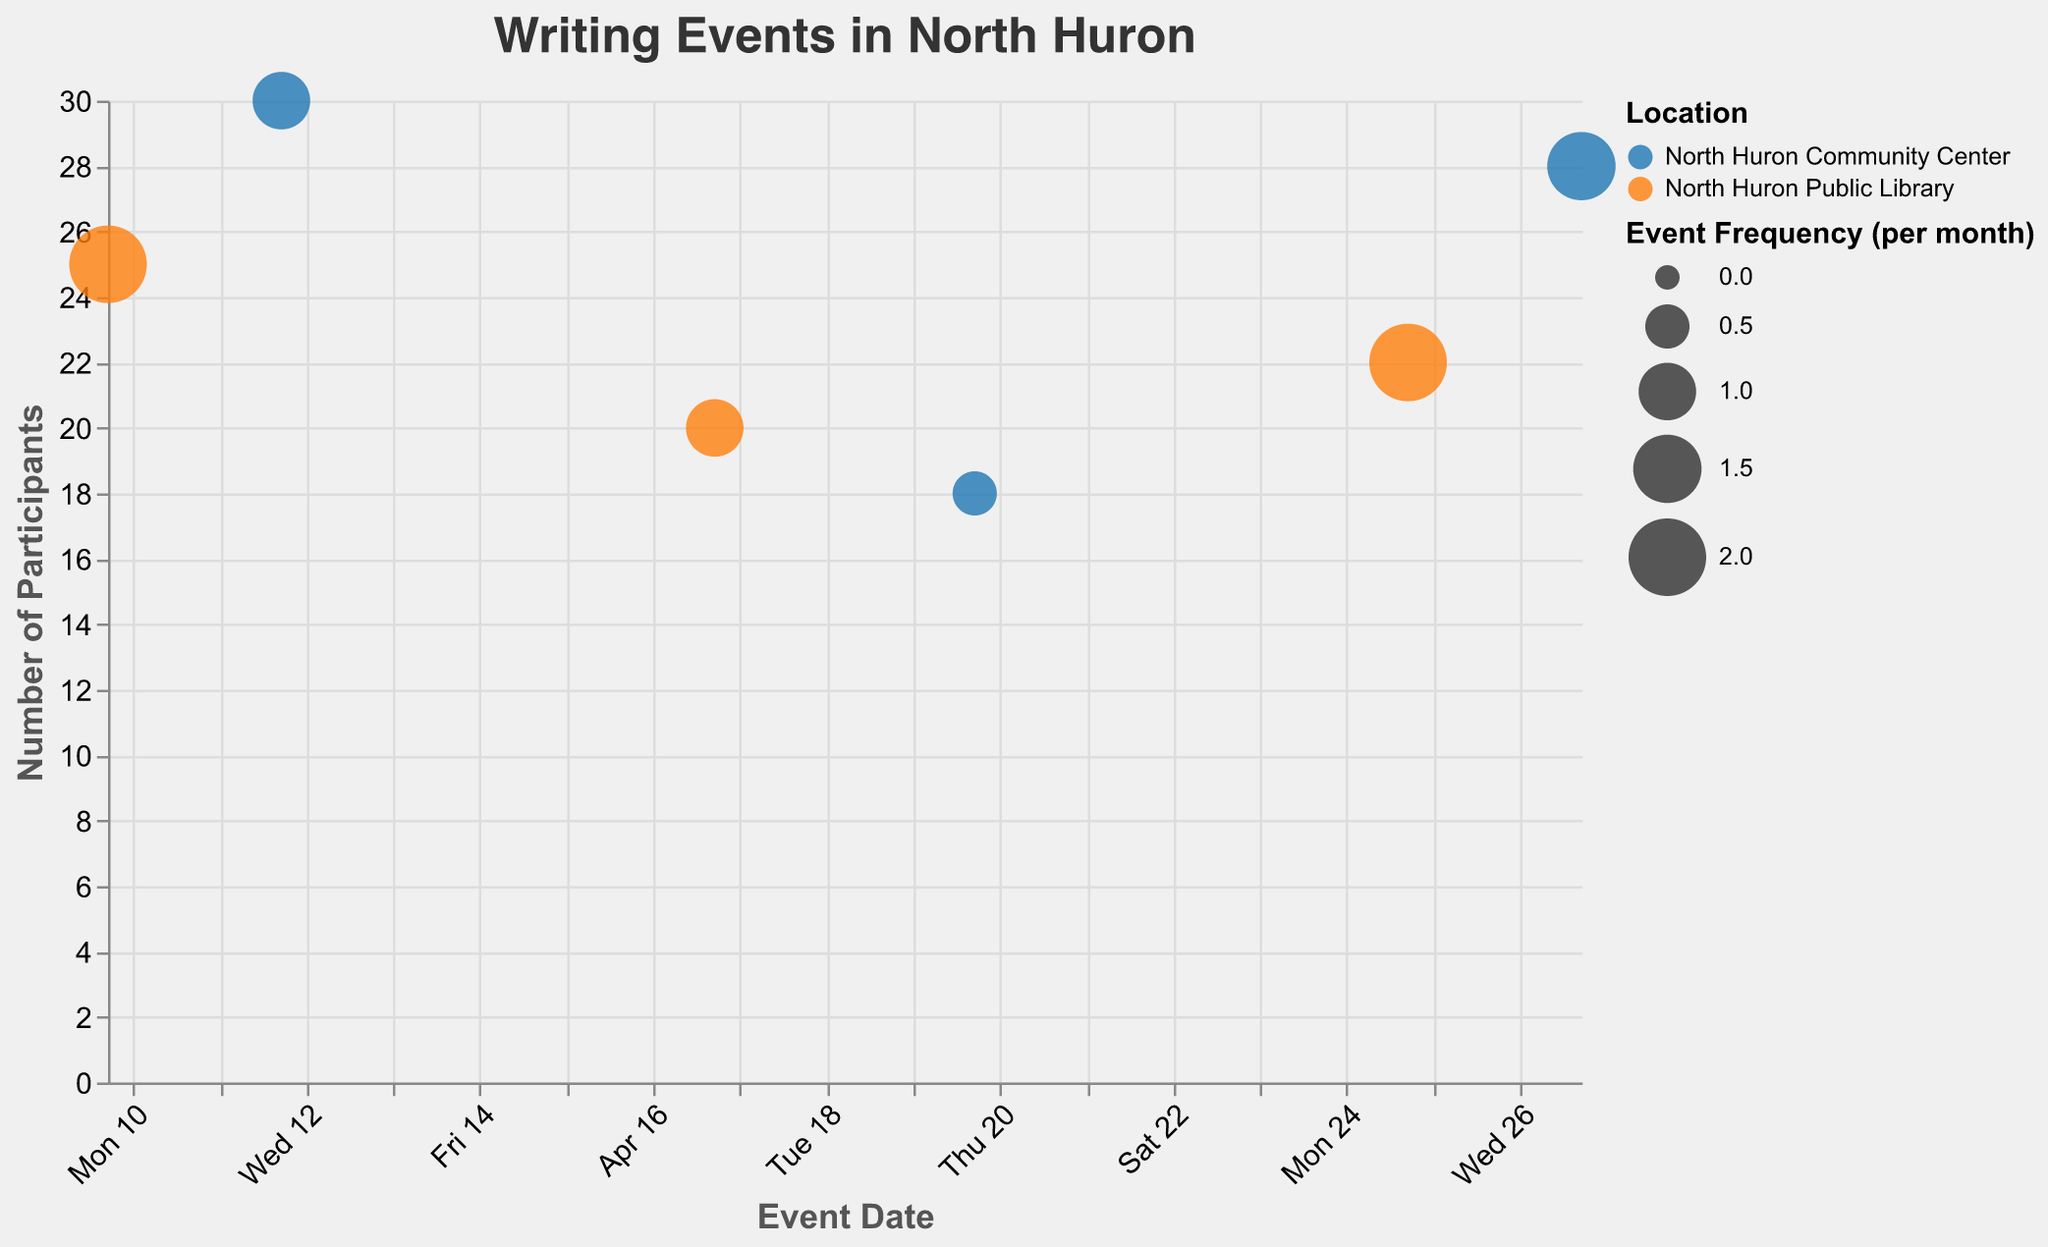What is the title of the chart? The title is displayed at the top of the chart.
Answer: "Writing Events in North Huron" How many participants attended the Screenwriting Class? Locate the data point on the chart with the tooltip showing "Event Name: Screenwriting Class," then check the "Number of Participants" in the tooltip.
Answer: 20 Which event has the highest number of participants? Compare all data points to find the one with the largest value under "Number of Participants."
Answer: Poetry Slam Which event is held most frequently each month? Compare the "Event Frequency (times per month)" values in the tooltip for each data point.
Answer: Creative Writing Workshop and Essay Writing Workshop Which age group attended the Journalistic Writing Seminar? Locate the data point for the "Journalistic Writing Seminar" and check the "Age Group" field in the tooltip.
Answer: 46-55 How does the number of participants for Fiction Writing Bootcamp compare to the Essay Writing Workshop? Find both events on the chart and compare their "Number of Participants" values.
Answer: Fiction Writing Bootcamp has more participants (28 vs. 22) At which location were more events held, North Huron Public Library or North Huron Community Center? Count the data points for each location by looking at the color-coded "Location" field in the legend.
Answer: Both locations have held 3 events each What is the gender distribution for the participants in the Poetry Slam? Find "Poetry Slam" on the chart and check the "Gender Distribution (M/F/O)" field in the tooltip.
Answer: 14/14/2 Which event had the smallest number of participants and what was the age group involved? Locate the smallest value in "Number of Participants," then check its associated "Event Name" and "Age Group."
Answer: Journalistic Writing Seminar; Age Group: 46-55 What is the overall range of the number of participants across all events? Identify the minimum and maximum number of participants from all data points.
Answer: 18 to 30 